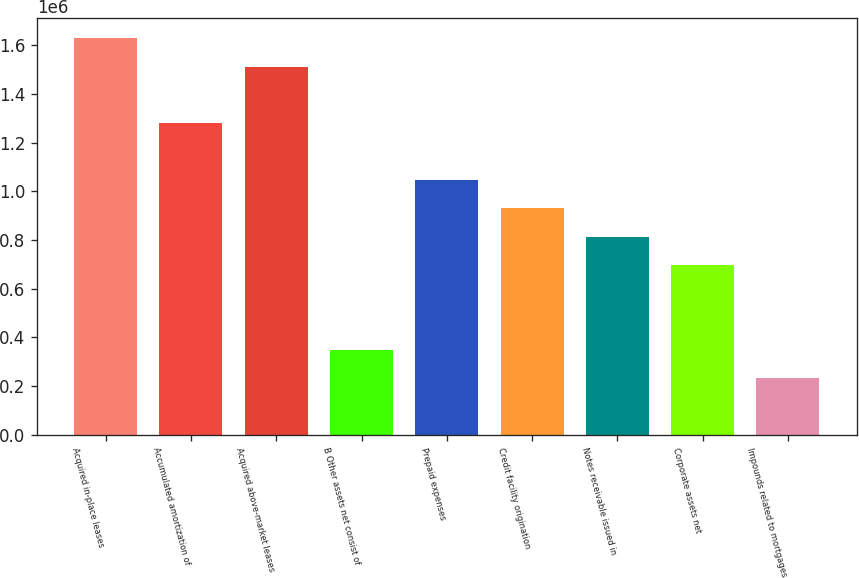<chart> <loc_0><loc_0><loc_500><loc_500><bar_chart><fcel>Acquired in-place leases<fcel>Accumulated amortization of<fcel>Acquired above-market leases<fcel>B Other assets net consist of<fcel>Prepaid expenses<fcel>Credit facility origination<fcel>Notes receivable issued in<fcel>Corporate assets net<fcel>Impounds related to mortgages<nl><fcel>1.62967e+06<fcel>1.28047e+06<fcel>1.51327e+06<fcel>349280<fcel>1.04768e+06<fcel>931276<fcel>814877<fcel>698478<fcel>232881<nl></chart> 